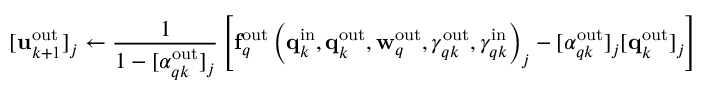<formula> <loc_0><loc_0><loc_500><loc_500>[ u _ { k + 1 } ^ { o u t } ] _ { j } \gets \frac { 1 } { 1 - [ \alpha _ { q k } ^ { o u t } ] _ { j } } \left [ f _ { q } ^ { o u t } \left ( q _ { k } ^ { i n } , q _ { k } ^ { o u t } , w _ { q } ^ { o u t } , \gamma _ { q k } ^ { o u t } , \gamma _ { q k } ^ { i n } \right ) _ { j } - [ \alpha _ { q k } ^ { o u t } ] _ { j } [ q _ { k } ^ { o u t } ] _ { j } \right ]</formula> 